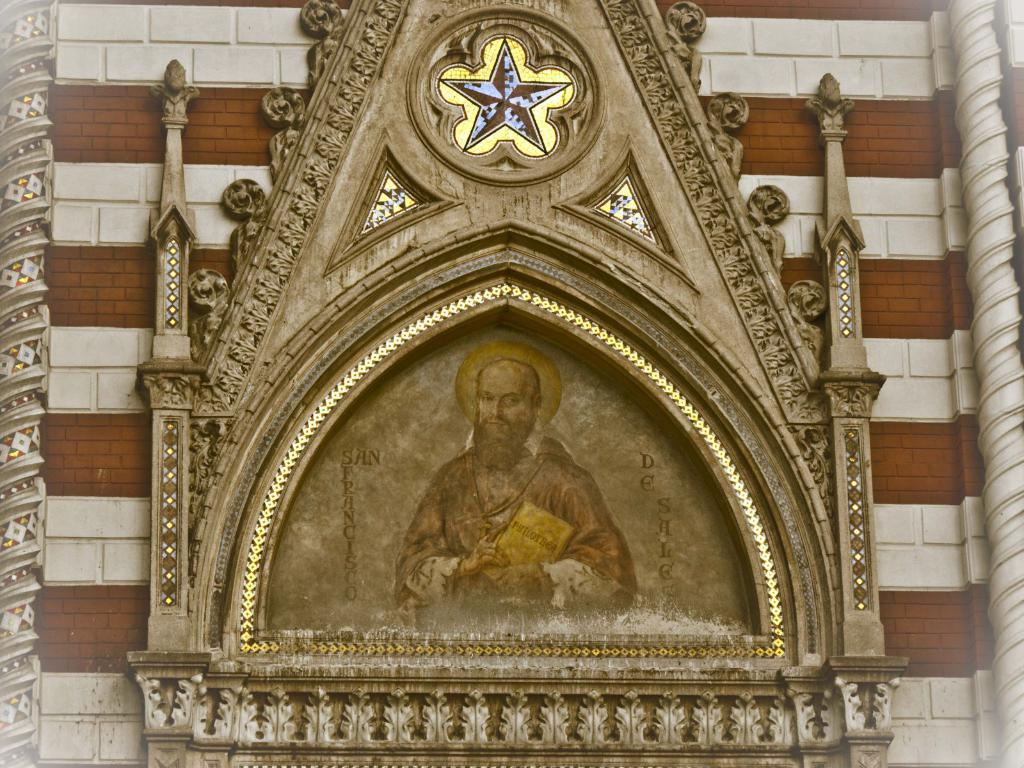What type of object is hanging on the wall in the image? There is a religious object on the wall in the image. Can you describe the person in the picture? The person in the picture is holding a book in their hand. How many kittens are playing with the book in the image? There are no kittens present in the image; the person is holding a book in their hand. What type of holiday is being celebrated in the image? There is no indication of a holiday being celebrated in the image. 